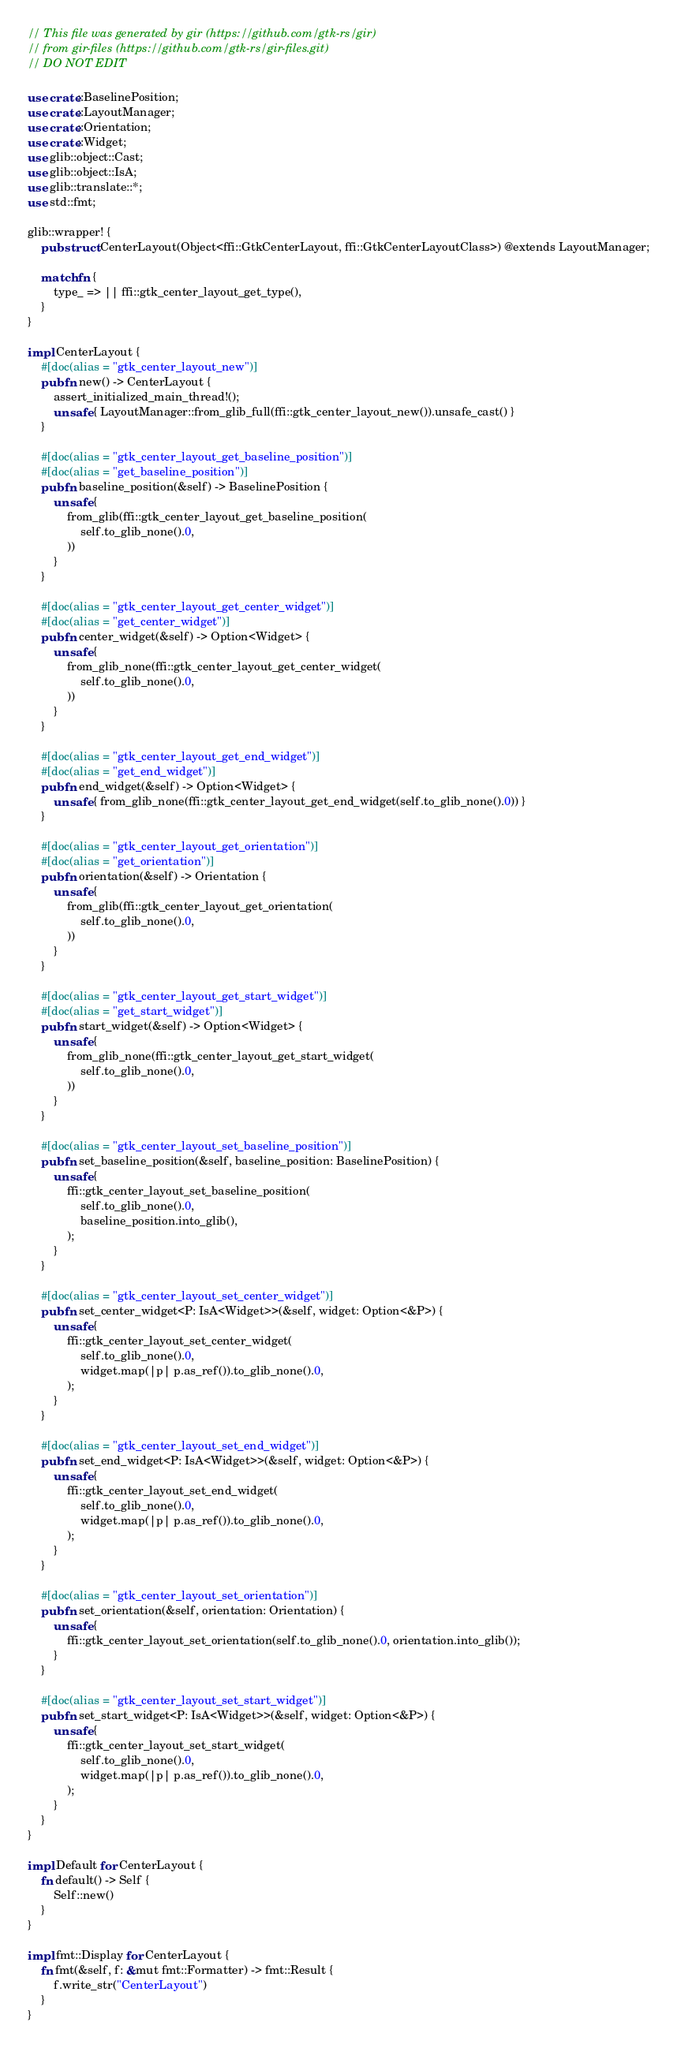<code> <loc_0><loc_0><loc_500><loc_500><_Rust_>// This file was generated by gir (https://github.com/gtk-rs/gir)
// from gir-files (https://github.com/gtk-rs/gir-files.git)
// DO NOT EDIT

use crate::BaselinePosition;
use crate::LayoutManager;
use crate::Orientation;
use crate::Widget;
use glib::object::Cast;
use glib::object::IsA;
use glib::translate::*;
use std::fmt;

glib::wrapper! {
    pub struct CenterLayout(Object<ffi::GtkCenterLayout, ffi::GtkCenterLayoutClass>) @extends LayoutManager;

    match fn {
        type_ => || ffi::gtk_center_layout_get_type(),
    }
}

impl CenterLayout {
    #[doc(alias = "gtk_center_layout_new")]
    pub fn new() -> CenterLayout {
        assert_initialized_main_thread!();
        unsafe { LayoutManager::from_glib_full(ffi::gtk_center_layout_new()).unsafe_cast() }
    }

    #[doc(alias = "gtk_center_layout_get_baseline_position")]
    #[doc(alias = "get_baseline_position")]
    pub fn baseline_position(&self) -> BaselinePosition {
        unsafe {
            from_glib(ffi::gtk_center_layout_get_baseline_position(
                self.to_glib_none().0,
            ))
        }
    }

    #[doc(alias = "gtk_center_layout_get_center_widget")]
    #[doc(alias = "get_center_widget")]
    pub fn center_widget(&self) -> Option<Widget> {
        unsafe {
            from_glib_none(ffi::gtk_center_layout_get_center_widget(
                self.to_glib_none().0,
            ))
        }
    }

    #[doc(alias = "gtk_center_layout_get_end_widget")]
    #[doc(alias = "get_end_widget")]
    pub fn end_widget(&self) -> Option<Widget> {
        unsafe { from_glib_none(ffi::gtk_center_layout_get_end_widget(self.to_glib_none().0)) }
    }

    #[doc(alias = "gtk_center_layout_get_orientation")]
    #[doc(alias = "get_orientation")]
    pub fn orientation(&self) -> Orientation {
        unsafe {
            from_glib(ffi::gtk_center_layout_get_orientation(
                self.to_glib_none().0,
            ))
        }
    }

    #[doc(alias = "gtk_center_layout_get_start_widget")]
    #[doc(alias = "get_start_widget")]
    pub fn start_widget(&self) -> Option<Widget> {
        unsafe {
            from_glib_none(ffi::gtk_center_layout_get_start_widget(
                self.to_glib_none().0,
            ))
        }
    }

    #[doc(alias = "gtk_center_layout_set_baseline_position")]
    pub fn set_baseline_position(&self, baseline_position: BaselinePosition) {
        unsafe {
            ffi::gtk_center_layout_set_baseline_position(
                self.to_glib_none().0,
                baseline_position.into_glib(),
            );
        }
    }

    #[doc(alias = "gtk_center_layout_set_center_widget")]
    pub fn set_center_widget<P: IsA<Widget>>(&self, widget: Option<&P>) {
        unsafe {
            ffi::gtk_center_layout_set_center_widget(
                self.to_glib_none().0,
                widget.map(|p| p.as_ref()).to_glib_none().0,
            );
        }
    }

    #[doc(alias = "gtk_center_layout_set_end_widget")]
    pub fn set_end_widget<P: IsA<Widget>>(&self, widget: Option<&P>) {
        unsafe {
            ffi::gtk_center_layout_set_end_widget(
                self.to_glib_none().0,
                widget.map(|p| p.as_ref()).to_glib_none().0,
            );
        }
    }

    #[doc(alias = "gtk_center_layout_set_orientation")]
    pub fn set_orientation(&self, orientation: Orientation) {
        unsafe {
            ffi::gtk_center_layout_set_orientation(self.to_glib_none().0, orientation.into_glib());
        }
    }

    #[doc(alias = "gtk_center_layout_set_start_widget")]
    pub fn set_start_widget<P: IsA<Widget>>(&self, widget: Option<&P>) {
        unsafe {
            ffi::gtk_center_layout_set_start_widget(
                self.to_glib_none().0,
                widget.map(|p| p.as_ref()).to_glib_none().0,
            );
        }
    }
}

impl Default for CenterLayout {
    fn default() -> Self {
        Self::new()
    }
}

impl fmt::Display for CenterLayout {
    fn fmt(&self, f: &mut fmt::Formatter) -> fmt::Result {
        f.write_str("CenterLayout")
    }
}
</code> 